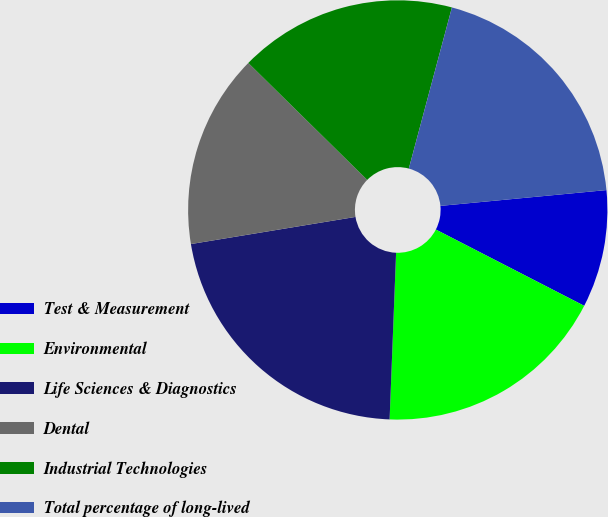Convert chart to OTSL. <chart><loc_0><loc_0><loc_500><loc_500><pie_chart><fcel>Test & Measurement<fcel>Environmental<fcel>Life Sciences & Diagnostics<fcel>Dental<fcel>Industrial Technologies<fcel>Total percentage of long-lived<nl><fcel>9.07%<fcel>18.06%<fcel>21.78%<fcel>14.97%<fcel>16.79%<fcel>19.33%<nl></chart> 